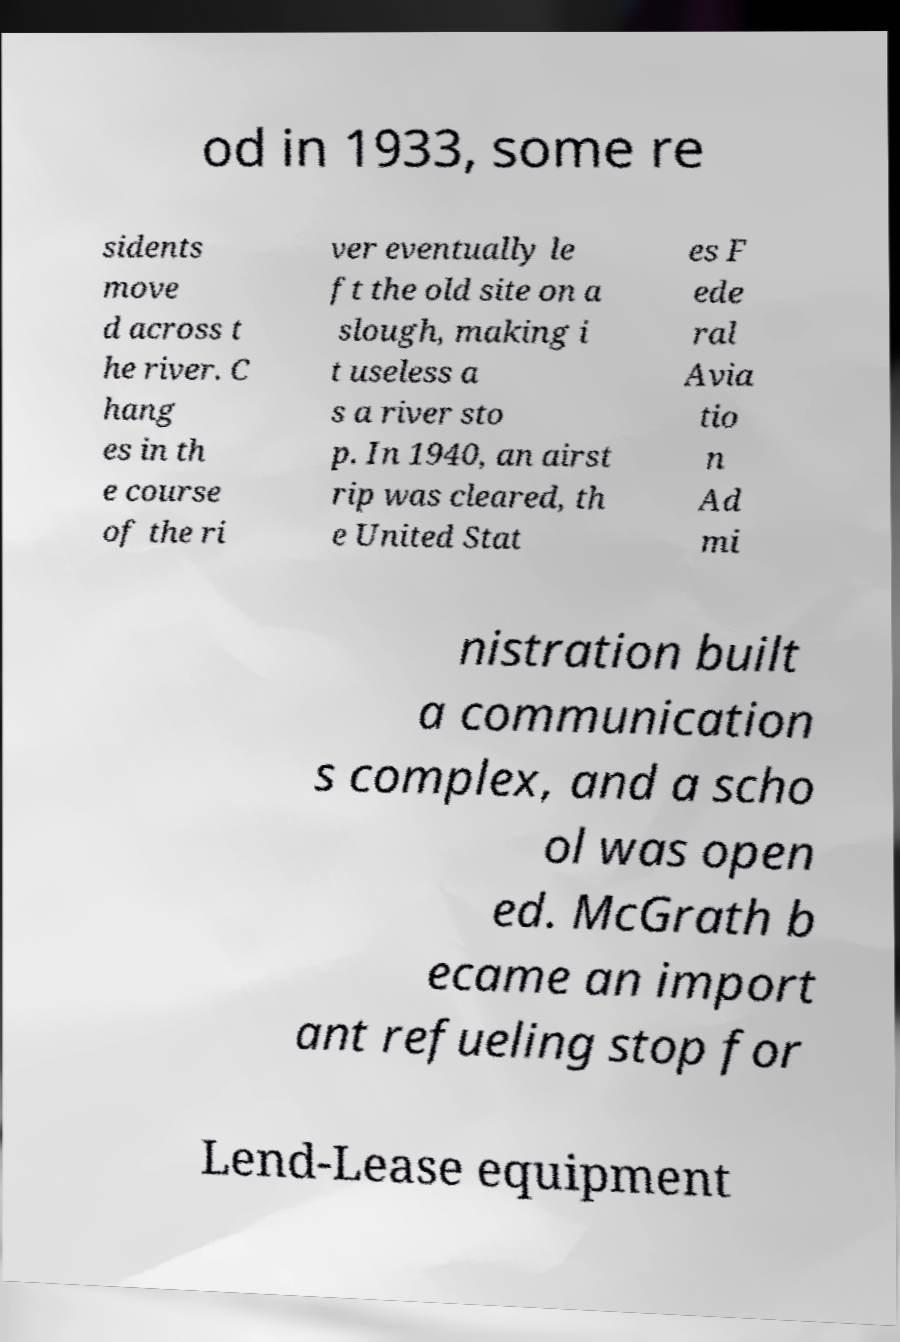What messages or text are displayed in this image? I need them in a readable, typed format. od in 1933, some re sidents move d across t he river. C hang es in th e course of the ri ver eventually le ft the old site on a slough, making i t useless a s a river sto p. In 1940, an airst rip was cleared, th e United Stat es F ede ral Avia tio n Ad mi nistration built a communication s complex, and a scho ol was open ed. McGrath b ecame an import ant refueling stop for Lend-Lease equipment 